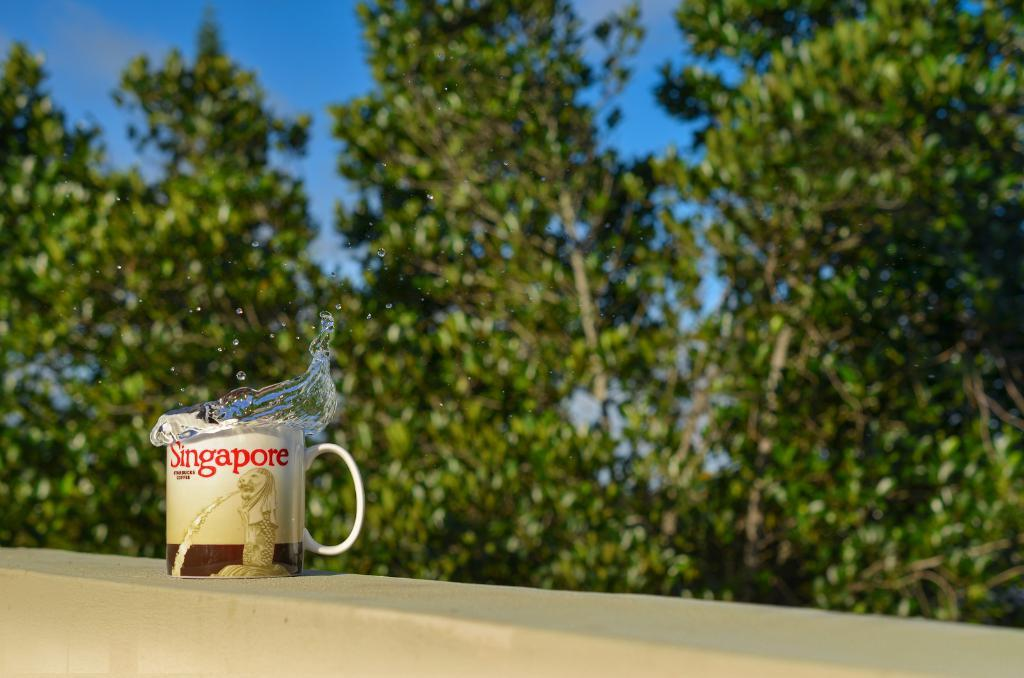What is inside the cup that is visible in the image? There is a cup filled with water in the image. Where is the cup located in the image? The cup is placed on the wall in the image. What can be seen in the background of the image? There is a group of trees and the sky visible in the background of the image. What time does the clock show in the image? There is no clock present in the image, so it is not possible to determine the time. 